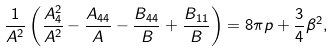Convert formula to latex. <formula><loc_0><loc_0><loc_500><loc_500>\frac { 1 } { A ^ { 2 } } \left ( \frac { A ^ { 2 } _ { 4 } } { A ^ { 2 } } - \frac { A _ { 4 4 } } { A } - \frac { B _ { 4 4 } } { B } + \frac { B _ { 1 1 } } { B } \right ) = 8 \pi p + \frac { 3 } { 4 } \beta ^ { 2 } ,</formula> 